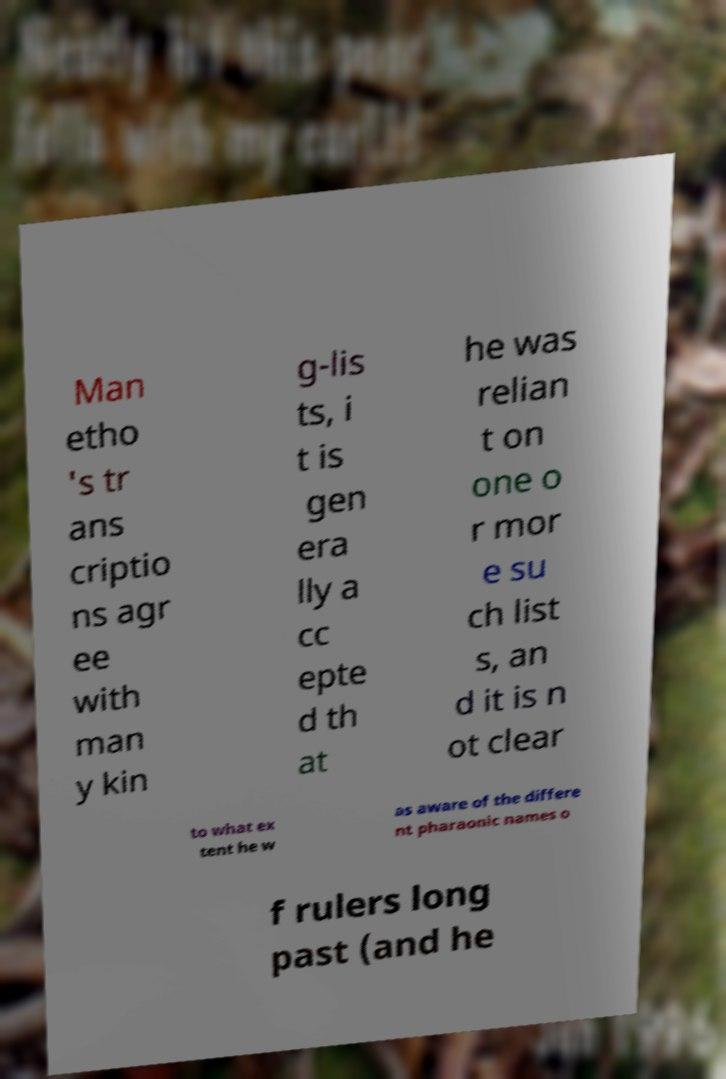For documentation purposes, I need the text within this image transcribed. Could you provide that? Man etho 's tr ans criptio ns agr ee with man y kin g-lis ts, i t is gen era lly a cc epte d th at he was relian t on one o r mor e su ch list s, an d it is n ot clear to what ex tent he w as aware of the differe nt pharaonic names o f rulers long past (and he 